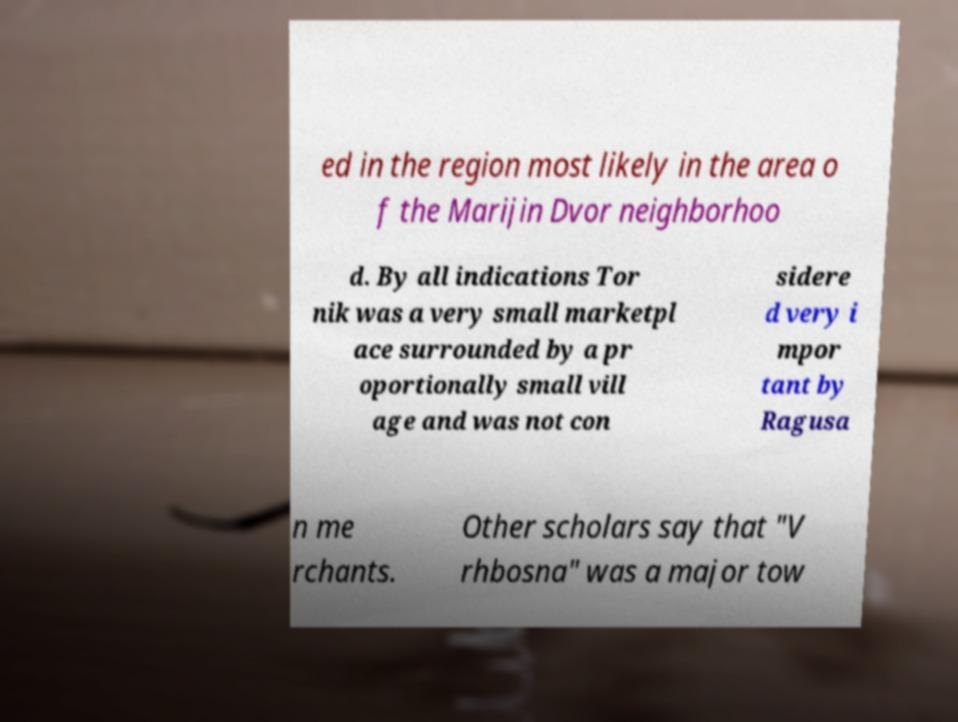I need the written content from this picture converted into text. Can you do that? ed in the region most likely in the area o f the Marijin Dvor neighborhoo d. By all indications Tor nik was a very small marketpl ace surrounded by a pr oportionally small vill age and was not con sidere d very i mpor tant by Ragusa n me rchants. Other scholars say that "V rhbosna" was a major tow 